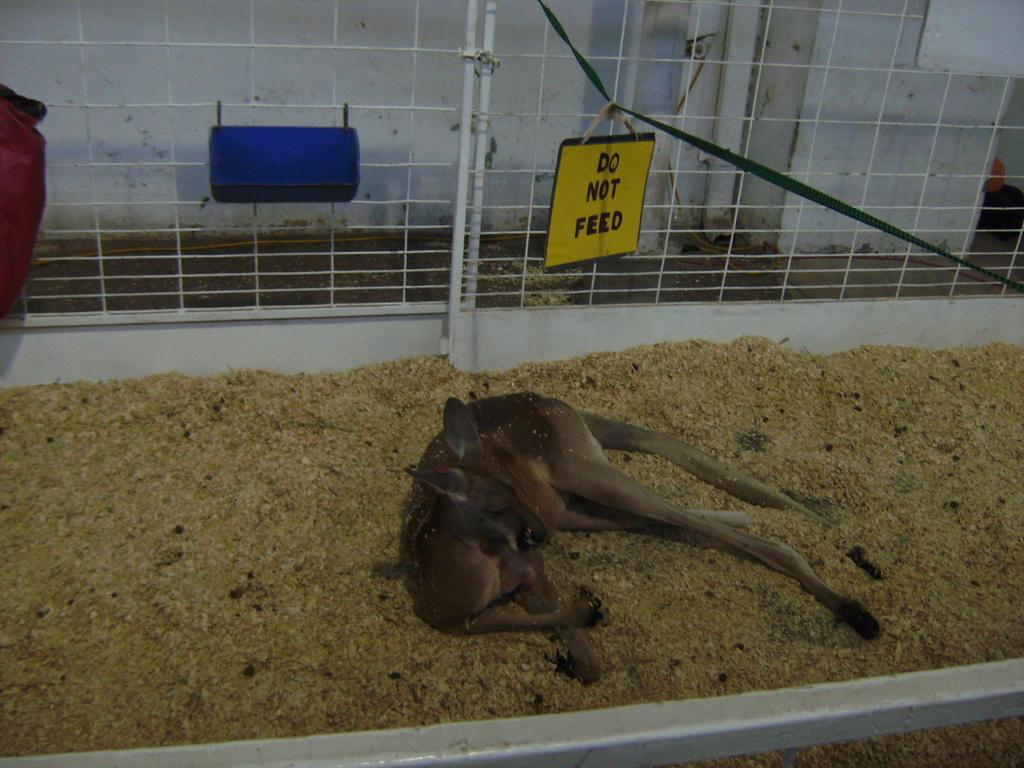What type of animal can be seen in the image? There is an animal in the image, but its specific type cannot be determined from the provided facts. Where is the animal located in the image? The animal is on the ground in the image. What can be seen in the background of the image? There is a pipe, a fence, and a wall in the background of the image. What type of face can be seen on the animal's hand in the image? There is no face or hand present on the animal in the image. 